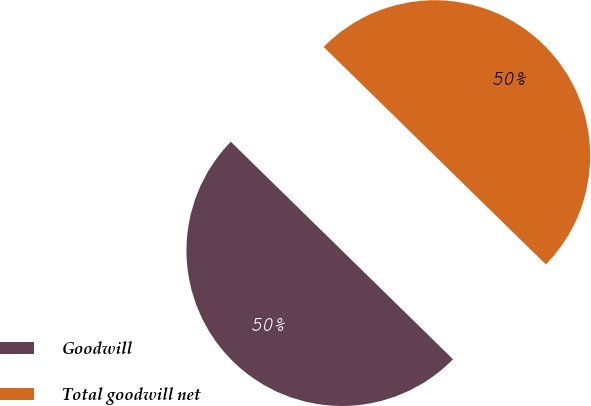<chart> <loc_0><loc_0><loc_500><loc_500><pie_chart><fcel>Goodwill<fcel>Total goodwill net<nl><fcel>50.0%<fcel>50.0%<nl></chart> 